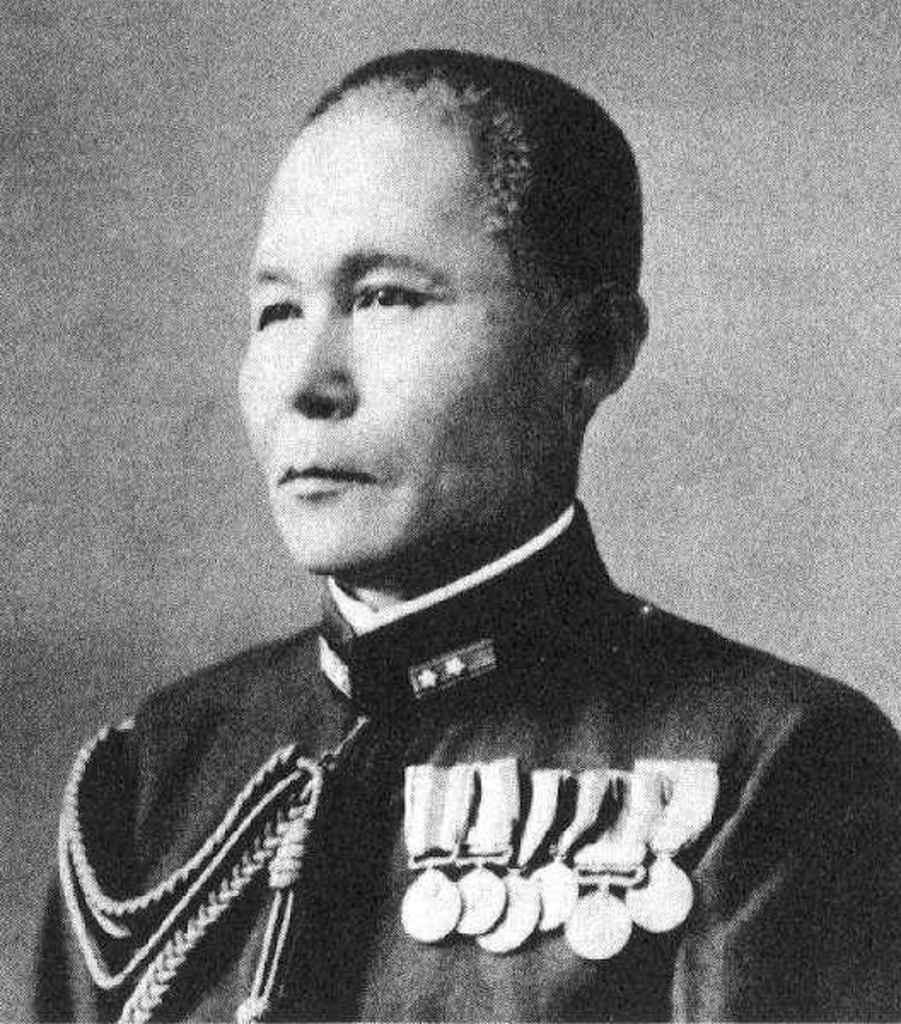What is the main subject of the image? The main subject of the image is a man. Can you describe any notable features of the man's attire? The man is wearing medals on his dress. What is the color scheme of the image? The image is black and white in color. What type of sweater is the man wearing in the image? There is no sweater visible in the image; the man is wearing a dress with medals. Can you describe the jellyfish swimming in the background of the image? There are no jellyfish present in the image; it is a black and white image of a man wearing medals. 